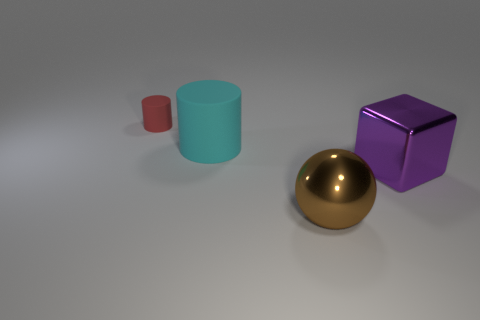Are the shadows consistent with the lighting in the scene? Yes, the shadows on the ground are consistent with the light source, suggesting a single light source above and to the left, creating a natural and cohesive lighting environment. Does the arrangement of the objects suggest any particular pattern or purpose? The arrangement of the objects does not suggest a pattern or specific purpose but rather appears to be a random placement of geometric shapes for visual or artistic effect. 